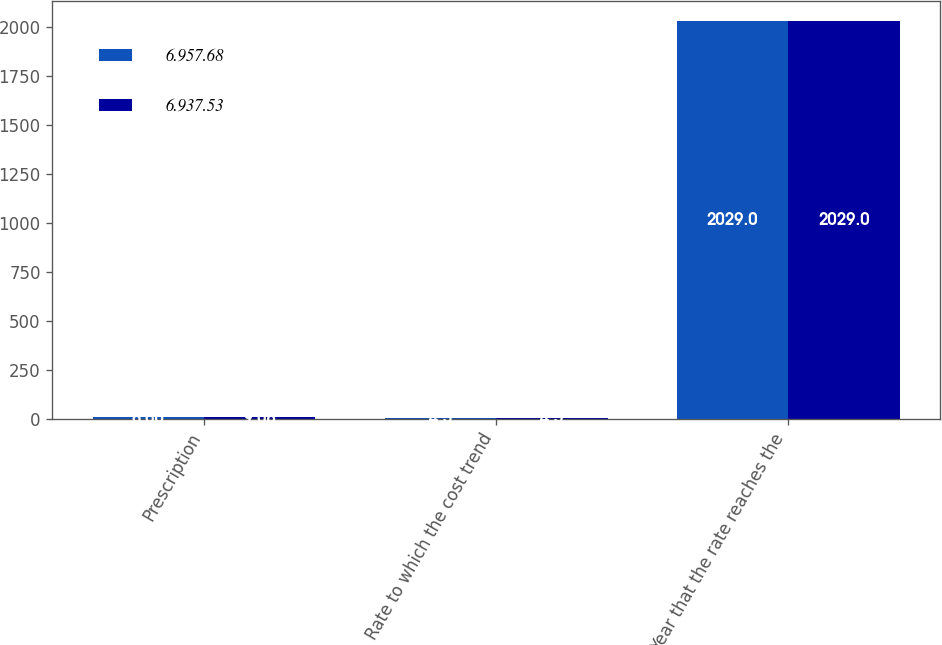Convert chart. <chart><loc_0><loc_0><loc_500><loc_500><stacked_bar_chart><ecel><fcel>Prescription<fcel>Rate to which the cost trend<fcel>Year that the rate reaches the<nl><fcel>6.957.68<fcel>8.66<fcel>4.5<fcel>2029<nl><fcel>6.937.53<fcel>9.08<fcel>4.5<fcel>2029<nl></chart> 